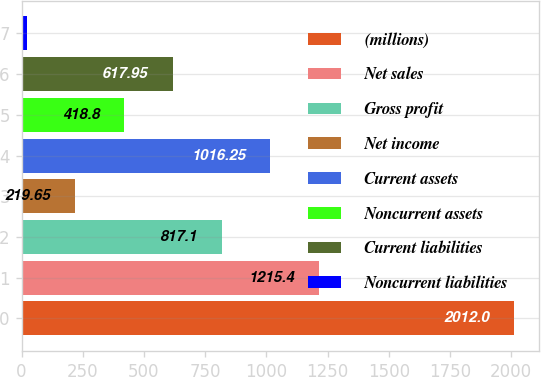<chart> <loc_0><loc_0><loc_500><loc_500><bar_chart><fcel>(millions)<fcel>Net sales<fcel>Gross profit<fcel>Net income<fcel>Current assets<fcel>Noncurrent assets<fcel>Current liabilities<fcel>Noncurrent liabilities<nl><fcel>2012<fcel>1215.4<fcel>817.1<fcel>219.65<fcel>1016.25<fcel>418.8<fcel>617.95<fcel>20.5<nl></chart> 